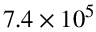<formula> <loc_0><loc_0><loc_500><loc_500>7 . 4 \times 1 0 ^ { 5 }</formula> 